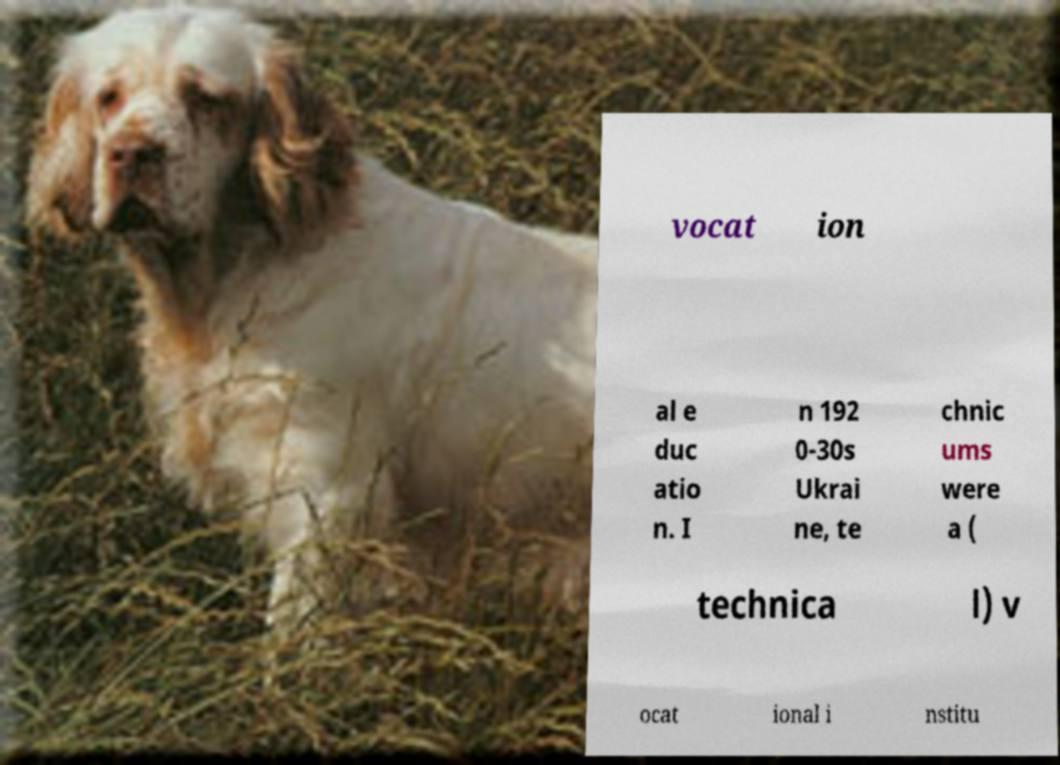Could you extract and type out the text from this image? vocat ion al e duc atio n. I n 192 0-30s Ukrai ne, te chnic ums were a ( technica l) v ocat ional i nstitu 